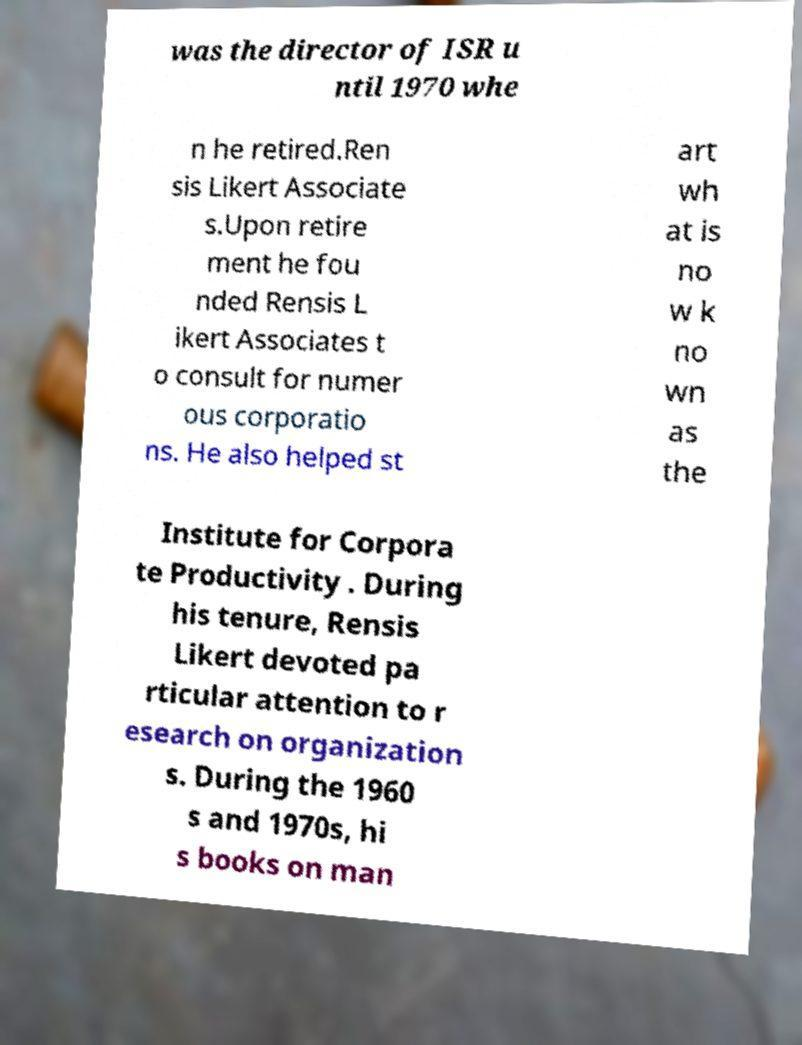Please read and relay the text visible in this image. What does it say? was the director of ISR u ntil 1970 whe n he retired.Ren sis Likert Associate s.Upon retire ment he fou nded Rensis L ikert Associates t o consult for numer ous corporatio ns. He also helped st art wh at is no w k no wn as the Institute for Corpora te Productivity . During his tenure, Rensis Likert devoted pa rticular attention to r esearch on organization s. During the 1960 s and 1970s, hi s books on man 